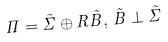<formula> <loc_0><loc_0><loc_500><loc_500>\Pi = \tilde { \Sigma } \oplus { R } \tilde { B } , \, \tilde { B } \perp \tilde { \Sigma }</formula> 